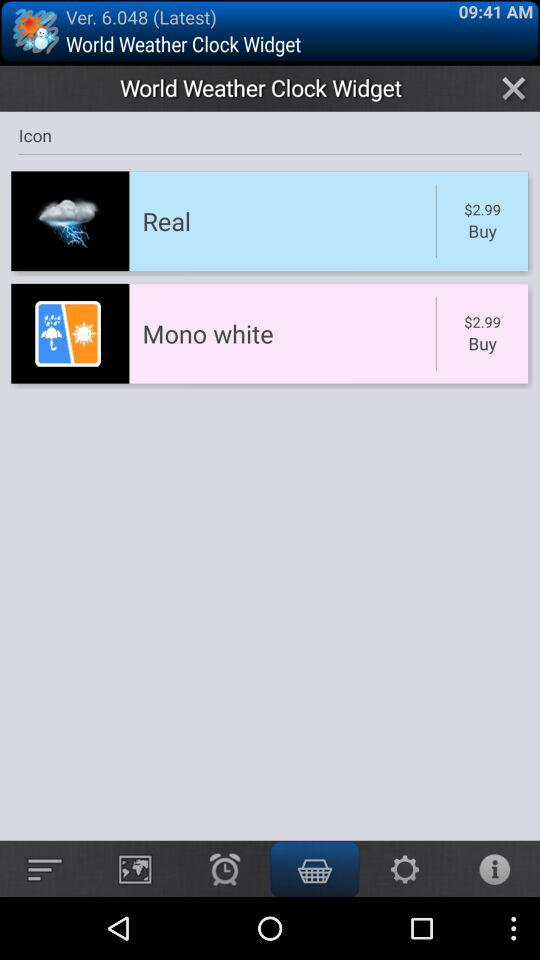What is the price of "Mono white" in the "World Weather Clock Widget"? The price of "Mono white" in the "World Weather Clock Widget" is $2.99. 